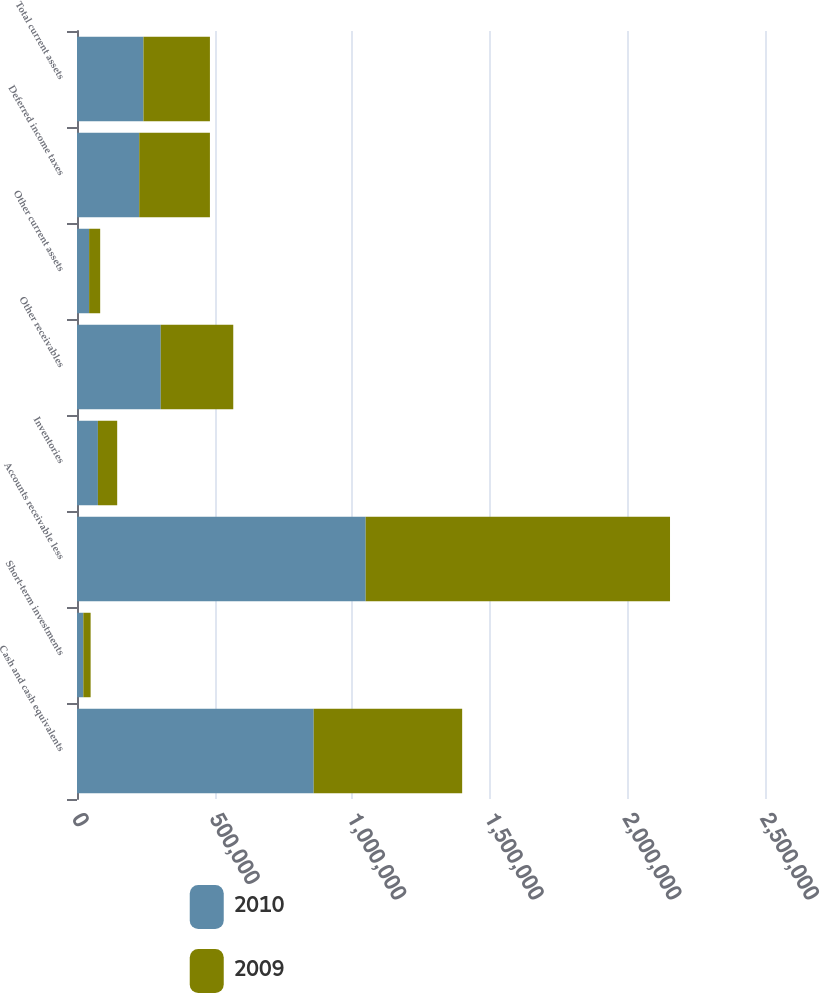Convert chart to OTSL. <chart><loc_0><loc_0><loc_500><loc_500><stacked_bar_chart><ecel><fcel>Cash and cash equivalents<fcel>Short-term investments<fcel>Accounts receivable less<fcel>Inventories<fcel>Other receivables<fcel>Other current assets<fcel>Deferred income taxes<fcel>Total current assets<nl><fcel>2010<fcel>860117<fcel>23003<fcel>1.04898e+06<fcel>76008<fcel>304366<fcel>43994<fcel>226060<fcel>241506<nl><fcel>2009<fcel>539459<fcel>26475<fcel>1.1059e+06<fcel>70041<fcel>263456<fcel>40234<fcel>256953<fcel>241506<nl></chart> 